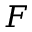<formula> <loc_0><loc_0><loc_500><loc_500>F</formula> 